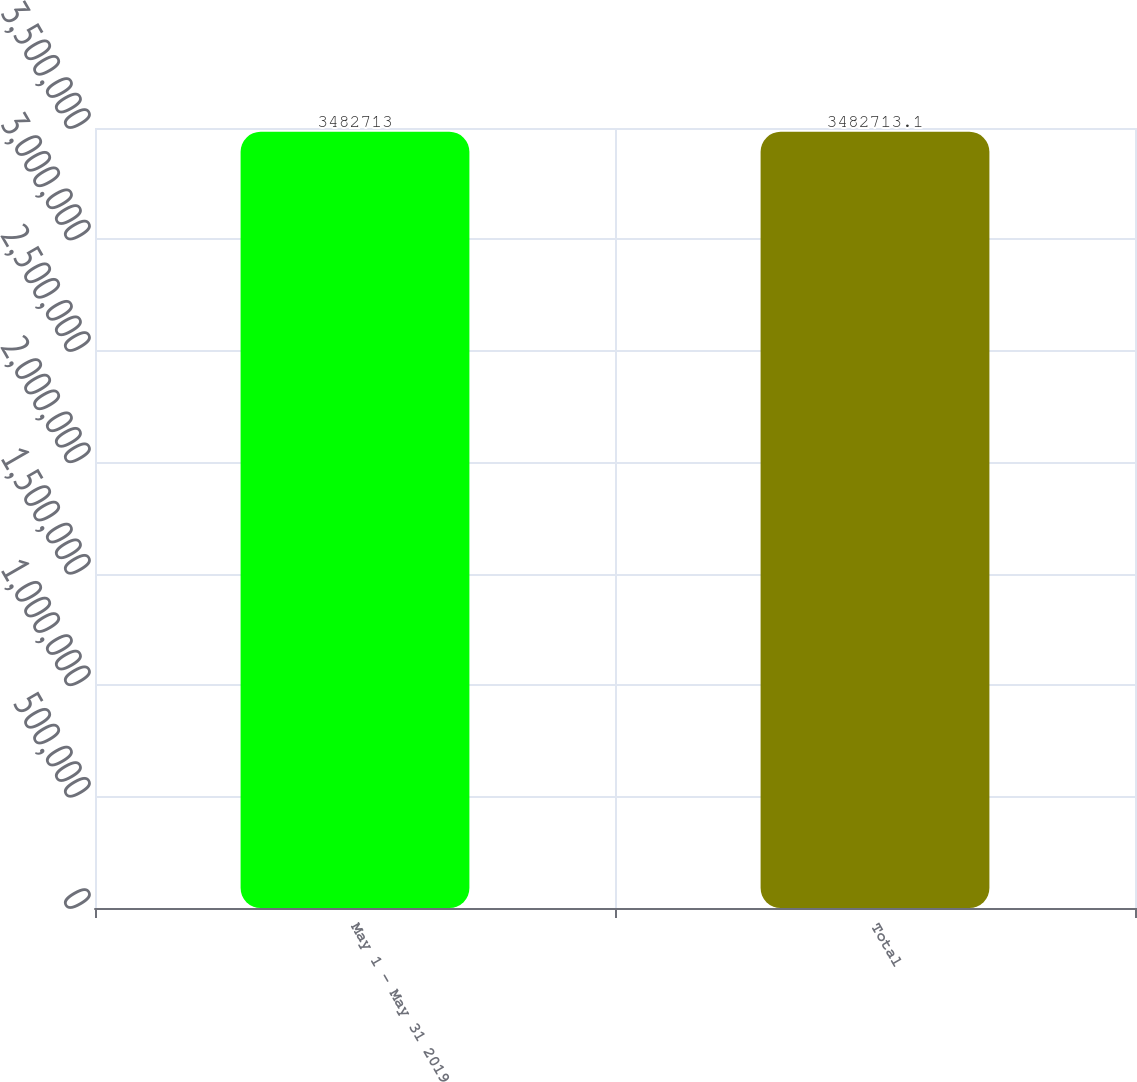<chart> <loc_0><loc_0><loc_500><loc_500><bar_chart><fcel>May 1 - May 31 2019<fcel>Total<nl><fcel>3.48271e+06<fcel>3.48271e+06<nl></chart> 